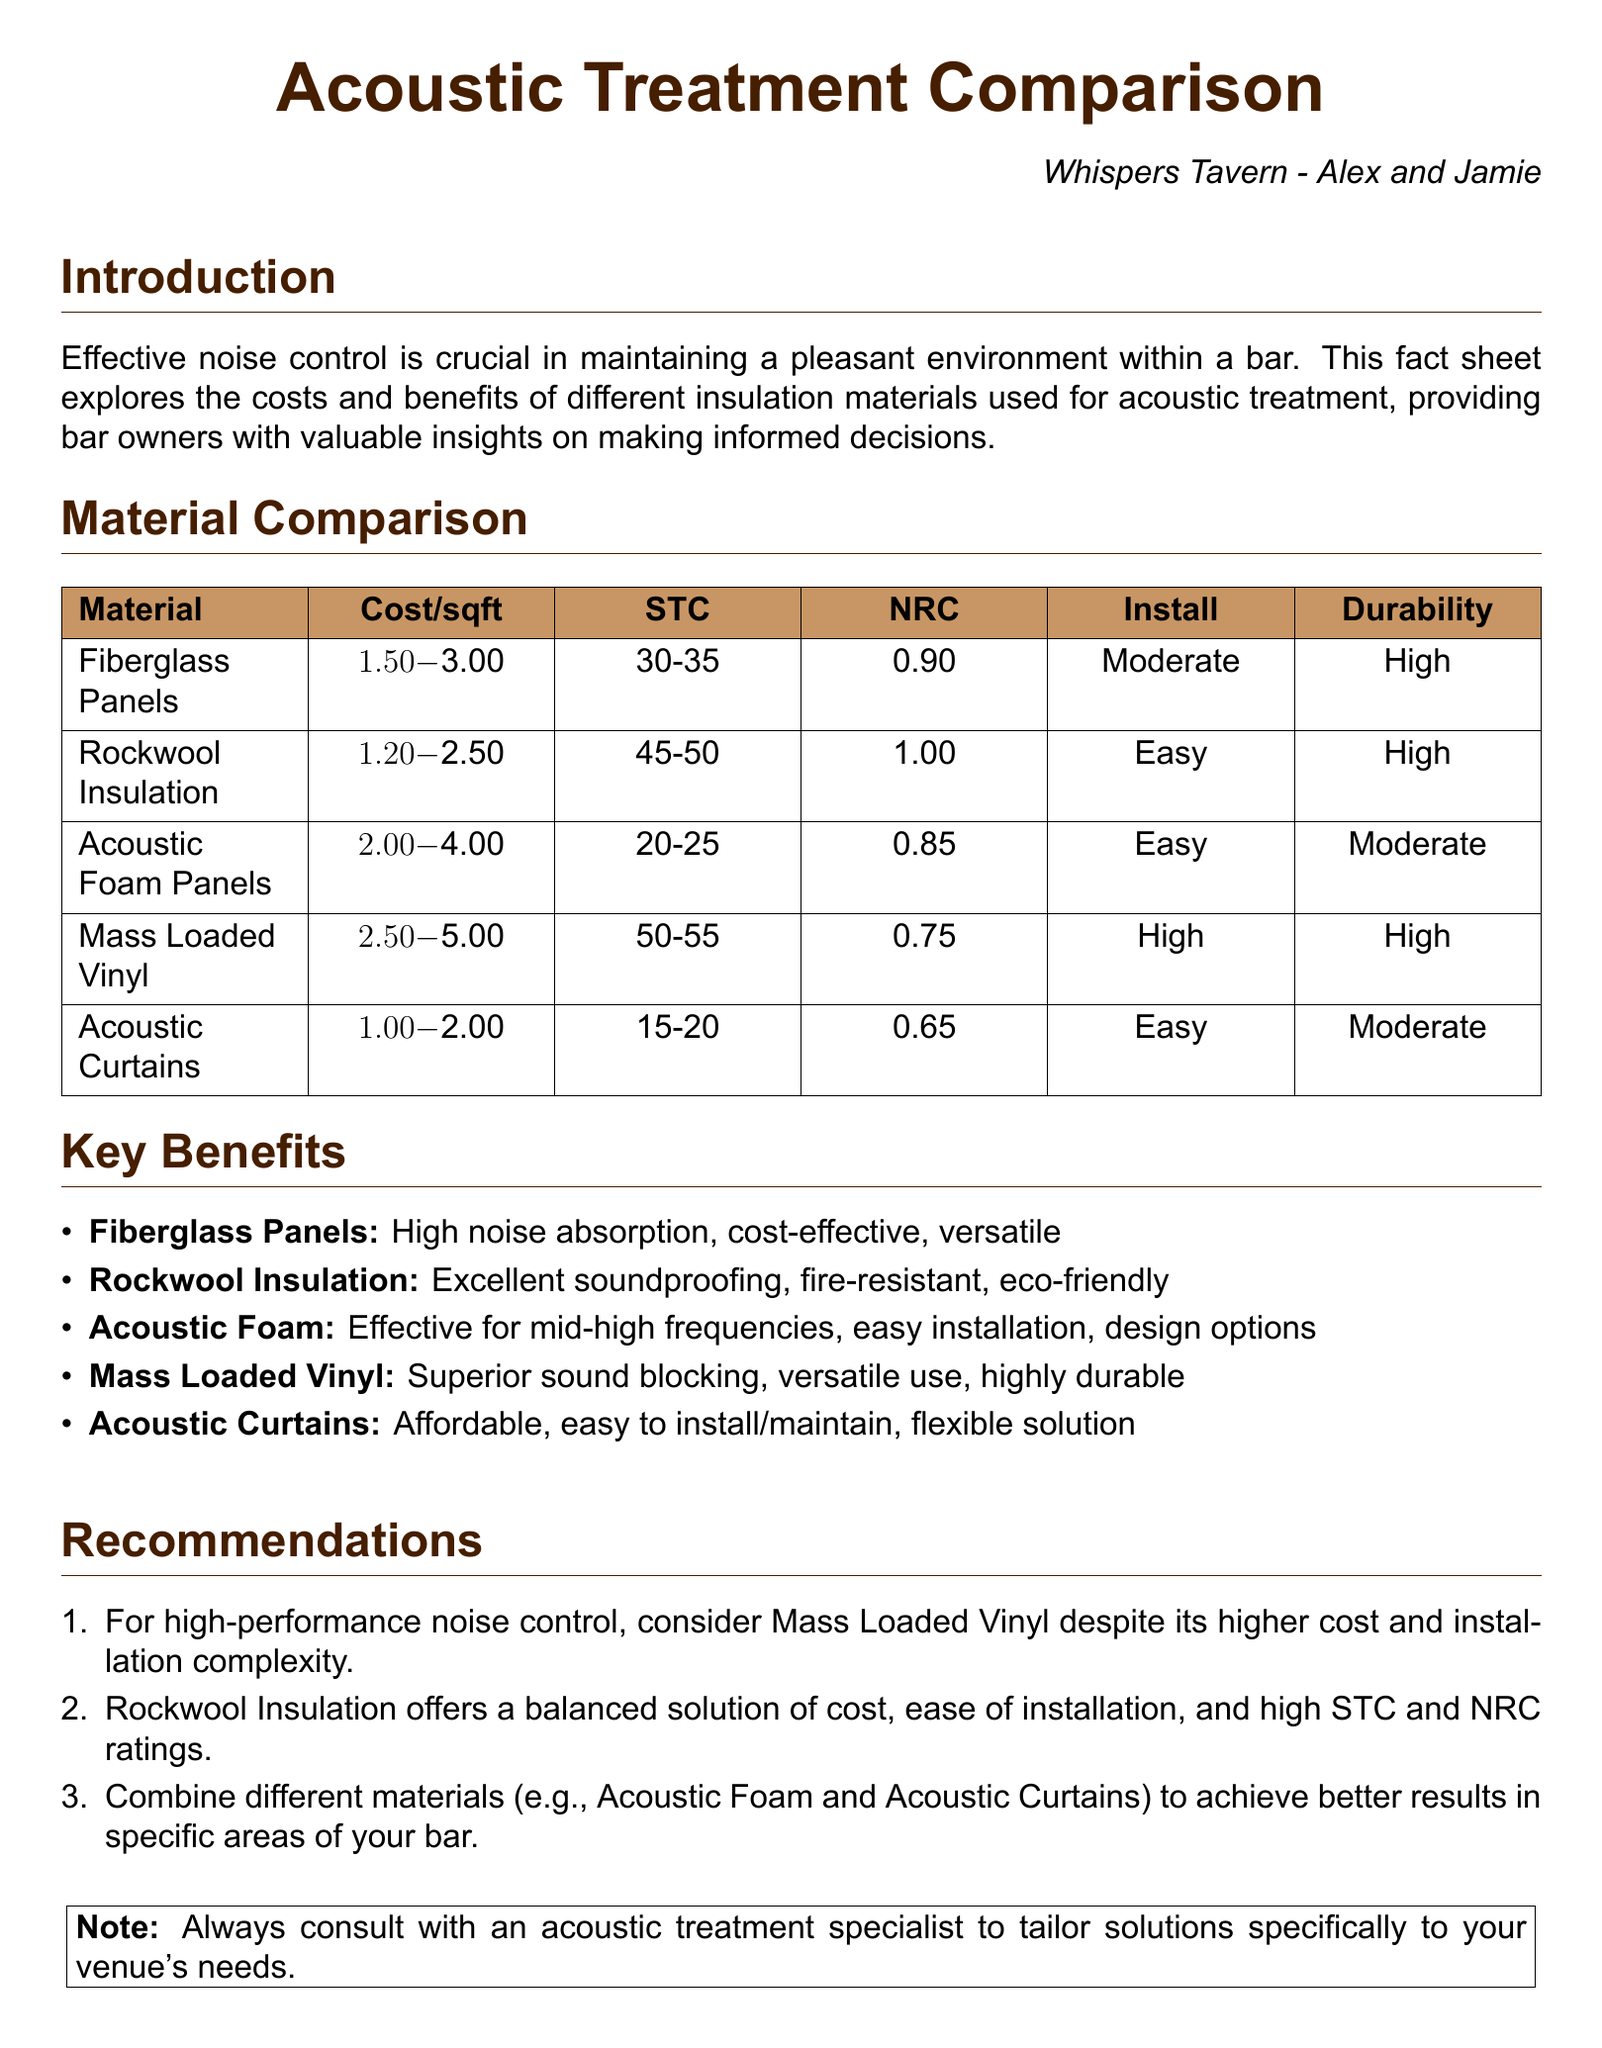What is the cost range for Rockwool Insulation? The cost range for Rockwool Insulation is found in the material comparison table.
Answer: $1.20-$2.50 What is the highest STC rating listed? The highest STC rating is found in the comparison table under the Rockwool Insulation and Mass Loaded Vinyl sections.
Answer: 55 What installation difficulty is associated with Acoustic Foam Panels? The installation difficulty for Acoustic Foam Panels is stated in the material comparison section.
Answer: Easy Which insulation material is described as fire-resistant? The fire-resistant insulation material is mentioned in the key benefits section.
Answer: Rockwool Insulation What combination of materials is recommended for better results? The recommendation for combining materials is provided in the recommendations section of the document.
Answer: Acoustic Foam and Acoustic Curtains How many materials are compared in the document? The count of different materials listed is directly related to the number of rows in the comparison table.
Answer: 5 What is the NRC value for Acoustic Curtains? The NRC value for Acoustic Curtains can be retrieved from the material comparison table.
Answer: 0.65 What is a key benefit of Fiberglass Panels? A key benefit of Fiberglass Panels is listed in the key benefits section.
Answer: High noise absorption What should be done before making noise control solutions? The document advises consulting an acoustic treatment specialist.
Answer: Consult with an acoustic treatment specialist 